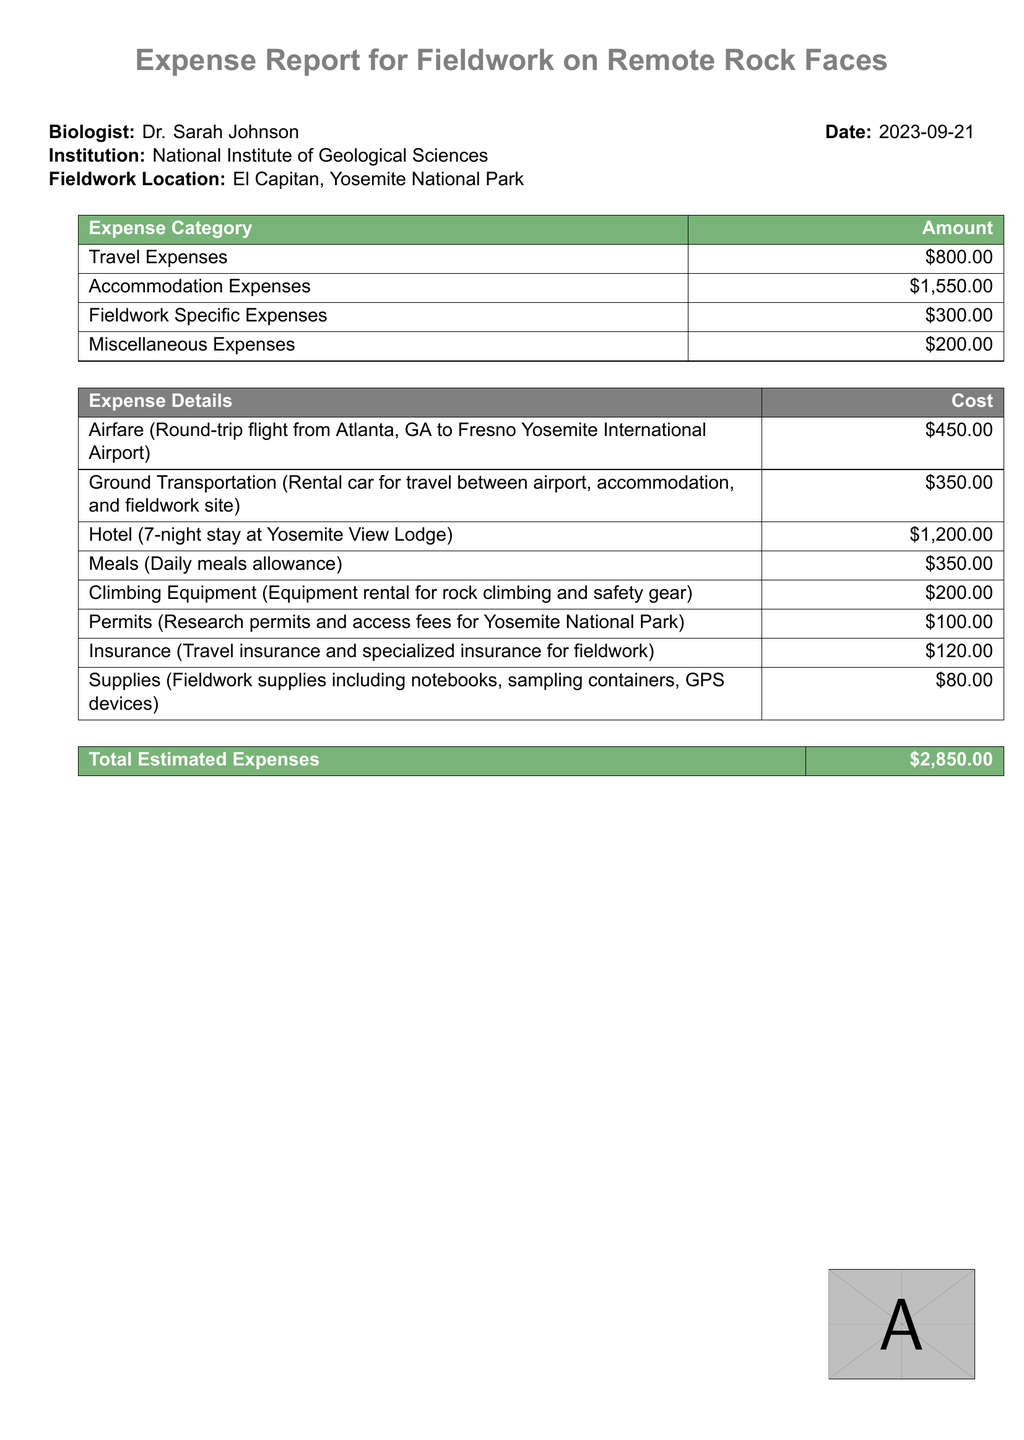What was the date of the expense report? The date of the expense report is stated clearly at the top of the document as 2023-09-21.
Answer: 2023-09-21 Who is the biologist mentioned in the expense report? The biologist's name is prominently displayed in the document.
Answer: Dr. Sarah Johnson How much was spent on accommodation expenses? The accommodation expenses are listed under their respective category in the expense table.
Answer: $1,550.00 What is the total amount for fieldwork specific expenses? The specific expenses related to fieldwork can be found in the categorized expense breakdown.
Answer: $300.00 How much did the airfare cost? The airfare cost is detailed under the breakdown of expenses.
Answer: $450.00 What was the cost of the hotel stay? The document specifies the hotel cost as part of the accommodation expenses.
Answer: $1,200.00 Which location was targeted for fieldwork? The fieldwork location is stated clearly in the document.
Answer: El Capitan, Yosemite National Park What category has the highest expense? The highest expense can be determined by comparing the amounts listed in the table.
Answer: Accommodation Expenses How much was allocated for meals? The meals allocation is part of the detailed cost breakdown in the report.
Answer: $350.00 